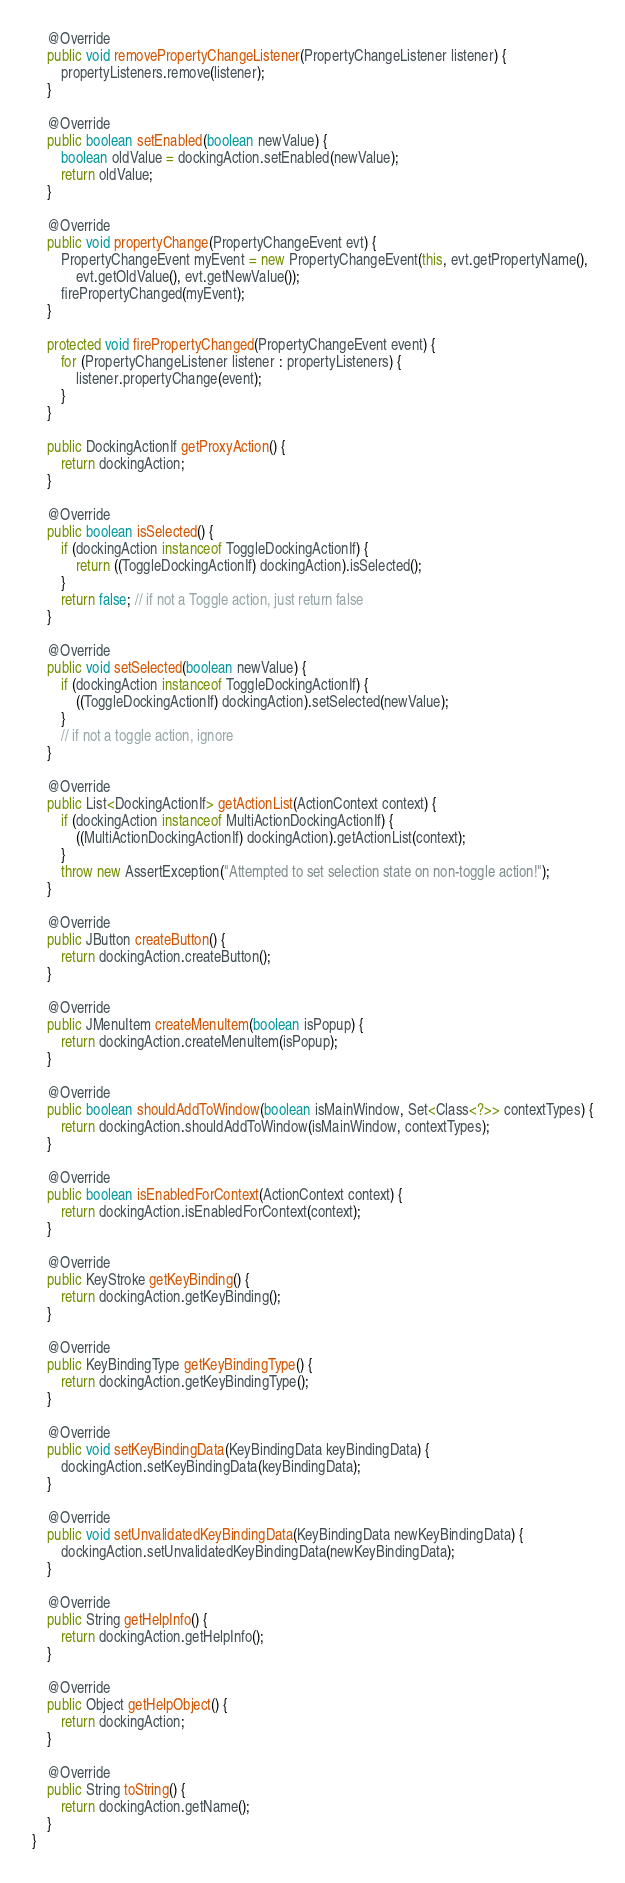<code> <loc_0><loc_0><loc_500><loc_500><_Java_>	@Override
	public void removePropertyChangeListener(PropertyChangeListener listener) {
		propertyListeners.remove(listener);
	}

	@Override
	public boolean setEnabled(boolean newValue) {
		boolean oldValue = dockingAction.setEnabled(newValue);
		return oldValue;
	}

	@Override
	public void propertyChange(PropertyChangeEvent evt) {
		PropertyChangeEvent myEvent = new PropertyChangeEvent(this, evt.getPropertyName(),
			evt.getOldValue(), evt.getNewValue());
		firePropertyChanged(myEvent);
	}

	protected void firePropertyChanged(PropertyChangeEvent event) {
		for (PropertyChangeListener listener : propertyListeners) {
			listener.propertyChange(event);
		}
	}

	public DockingActionIf getProxyAction() {
		return dockingAction;
	}

	@Override
	public boolean isSelected() {
		if (dockingAction instanceof ToggleDockingActionIf) {
			return ((ToggleDockingActionIf) dockingAction).isSelected();
		}
		return false; // if not a Toggle action, just return false
	}

	@Override
	public void setSelected(boolean newValue) {
		if (dockingAction instanceof ToggleDockingActionIf) {
			((ToggleDockingActionIf) dockingAction).setSelected(newValue);
		}
		// if not a toggle action, ignore
	}

	@Override
	public List<DockingActionIf> getActionList(ActionContext context) {
		if (dockingAction instanceof MultiActionDockingActionIf) {
			((MultiActionDockingActionIf) dockingAction).getActionList(context);
		}
		throw new AssertException("Attempted to set selection state on non-toggle action!");
	}

	@Override
	public JButton createButton() {
		return dockingAction.createButton();
	}

	@Override
	public JMenuItem createMenuItem(boolean isPopup) {
		return dockingAction.createMenuItem(isPopup);
	}

	@Override
	public boolean shouldAddToWindow(boolean isMainWindow, Set<Class<?>> contextTypes) {
		return dockingAction.shouldAddToWindow(isMainWindow, contextTypes);
	}

	@Override
	public boolean isEnabledForContext(ActionContext context) {
		return dockingAction.isEnabledForContext(context);
	}

	@Override
	public KeyStroke getKeyBinding() {
		return dockingAction.getKeyBinding();
	}

	@Override
	public KeyBindingType getKeyBindingType() {
		return dockingAction.getKeyBindingType();
	}

	@Override
	public void setKeyBindingData(KeyBindingData keyBindingData) {
		dockingAction.setKeyBindingData(keyBindingData);
	}

	@Override
	public void setUnvalidatedKeyBindingData(KeyBindingData newKeyBindingData) {
		dockingAction.setUnvalidatedKeyBindingData(newKeyBindingData);
	}

	@Override
	public String getHelpInfo() {
		return dockingAction.getHelpInfo();
	}

	@Override
	public Object getHelpObject() {
		return dockingAction;
	}

	@Override
	public String toString() {
		return dockingAction.getName();
	}
}
</code> 